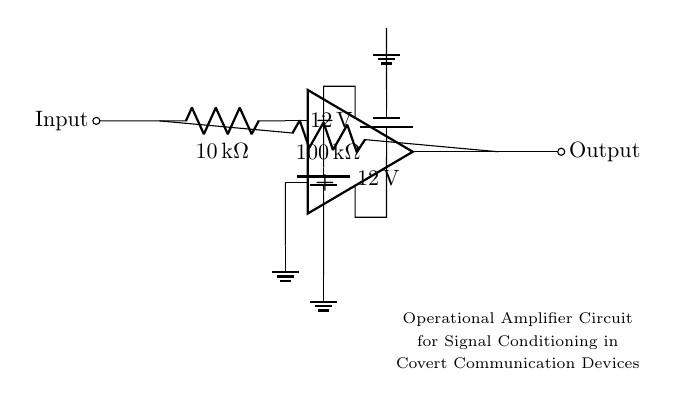What is the power supply voltage for the op-amp? The circuit shows two batteries, each labeled with a voltage of 12 volts, indicating that the op-amp is powered by 12 volts.
Answer: 12 volts What are the resistor values used in the circuit? The circuit diagram indicates a resistor labeled with a value of 10 kilo-ohms and another resistor with a value of 100 kilo-ohms, showing the resistors used.
Answer: 10 kilo-ohm and 100 kilo-ohm Where is the ground connection in the circuit? The circuit diagram shows two ground nodes at the bottom connected to the power supply and input; these connections indicate the reference point for voltage measurements and signal conditioning.
Answer: At the op-amp's non-inverting terminal end What is the purpose of the resistor between the input and output? The resistor connected from the output to the input is utilized for feedback in the operational amplifier circuit, which adjusts the gain and stabilizes the circuit operation.
Answer: Feedback What configuration is this operational amplifier using? The circuit shows that the input is connected to the inverting terminal and the output is fed back to the input via a resistor, indicative of an inverting amplifier configuration.
Answer: Inverting amplifier How do the voltages influence the op-amp operation? The dual supply of 12 volts allows the op-amp to operate in a symmetric range, enabling it to amplify AC signals effectively without clipping, which is essential for signal conditioning in covert devices.
Answer: Symmetric operation What type of signal conditioning does this circuit assist with? The inverting configuration and use of resistors suggest that the circuit is designed to amplify or attenuate audio or other low-level signals for covert communication, making it suitable for enhancing weak signals.
Answer: Amplification 